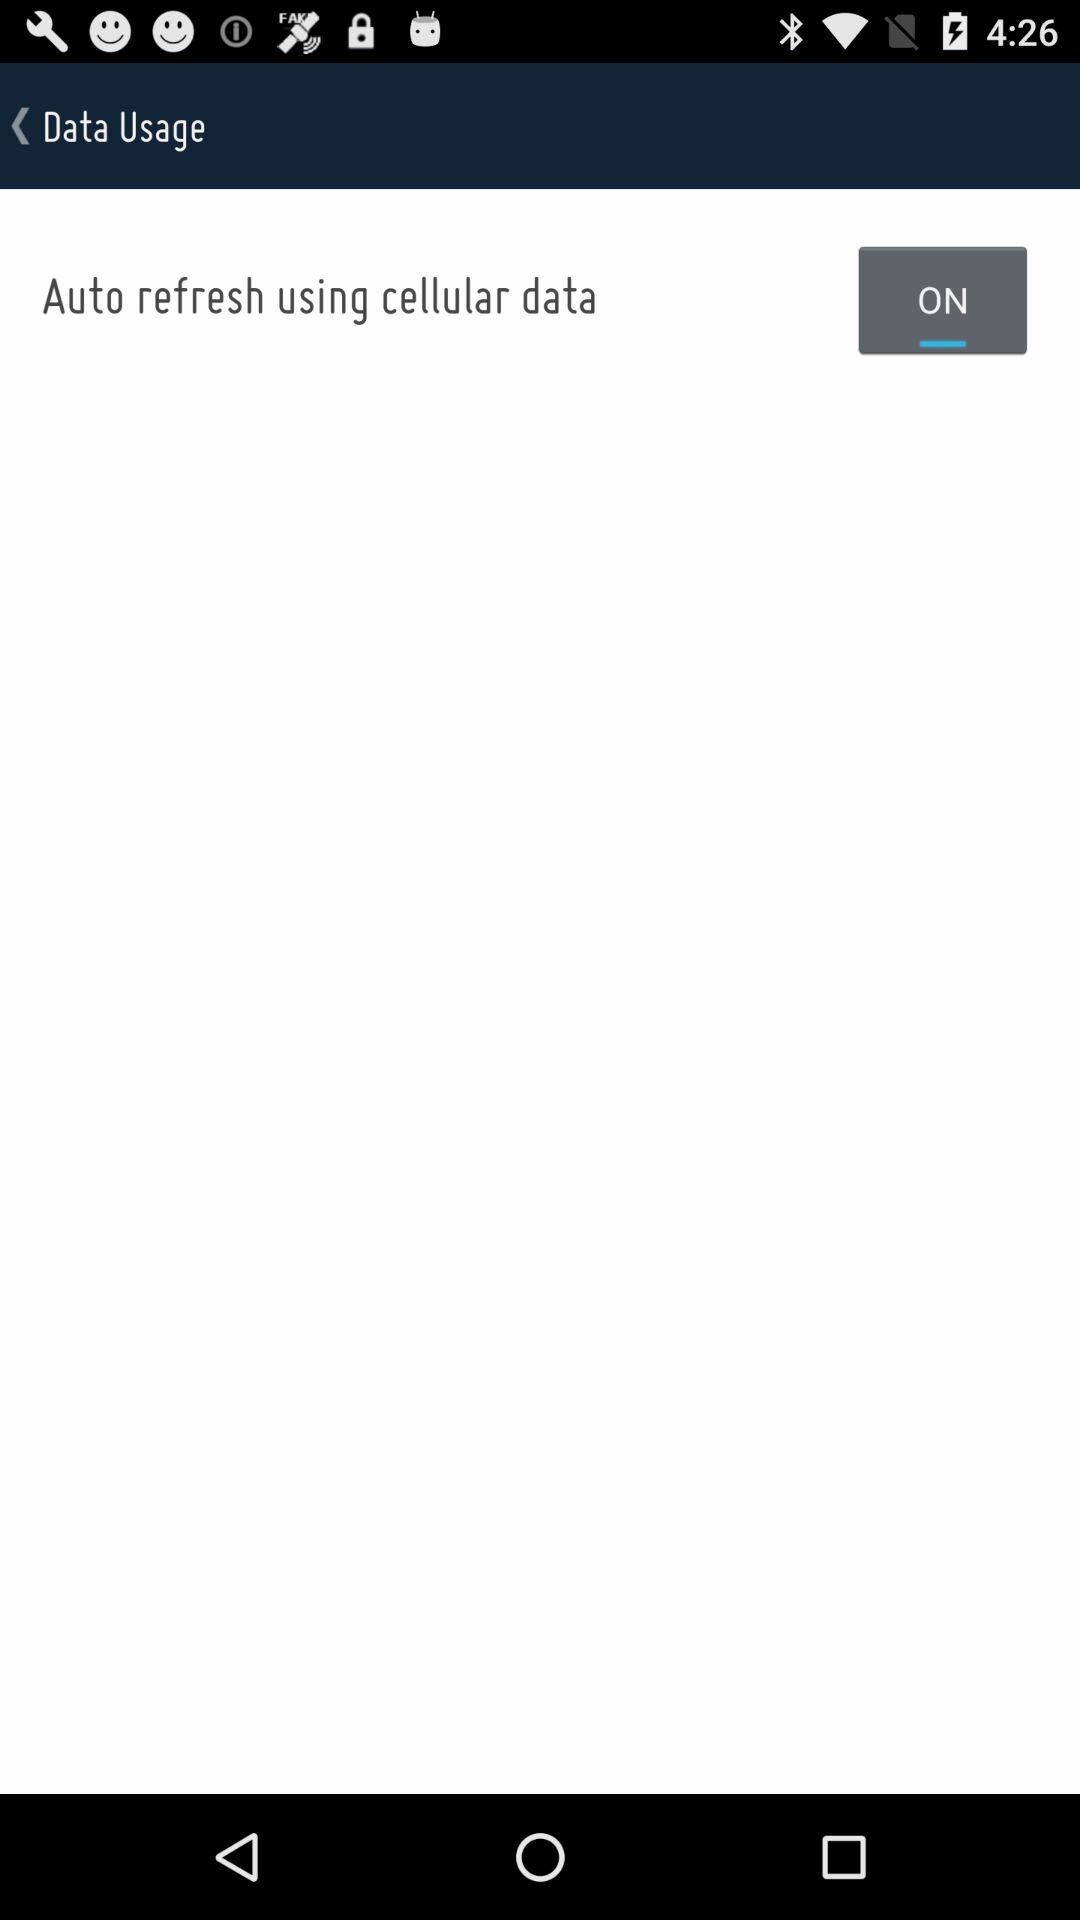What is the status of "Auto refresh using cellular data"? The status is "on". 